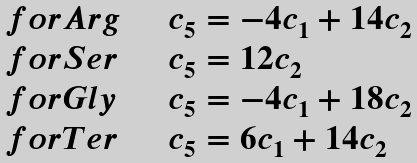<formula> <loc_0><loc_0><loc_500><loc_500>\begin{array} { l l } f o r A r g & \quad c _ { 5 } = - 4 c _ { 1 } + 1 4 c _ { 2 } \\ f o r S e r & \quad c _ { 5 } = 1 2 c _ { 2 } \\ f o r G l y & \quad c _ { 5 } = - 4 c _ { 1 } + 1 8 c _ { 2 } \\ f o r T e r & \quad c _ { 5 } = 6 c _ { 1 } + 1 4 c _ { 2 } \\ \end{array}</formula> 